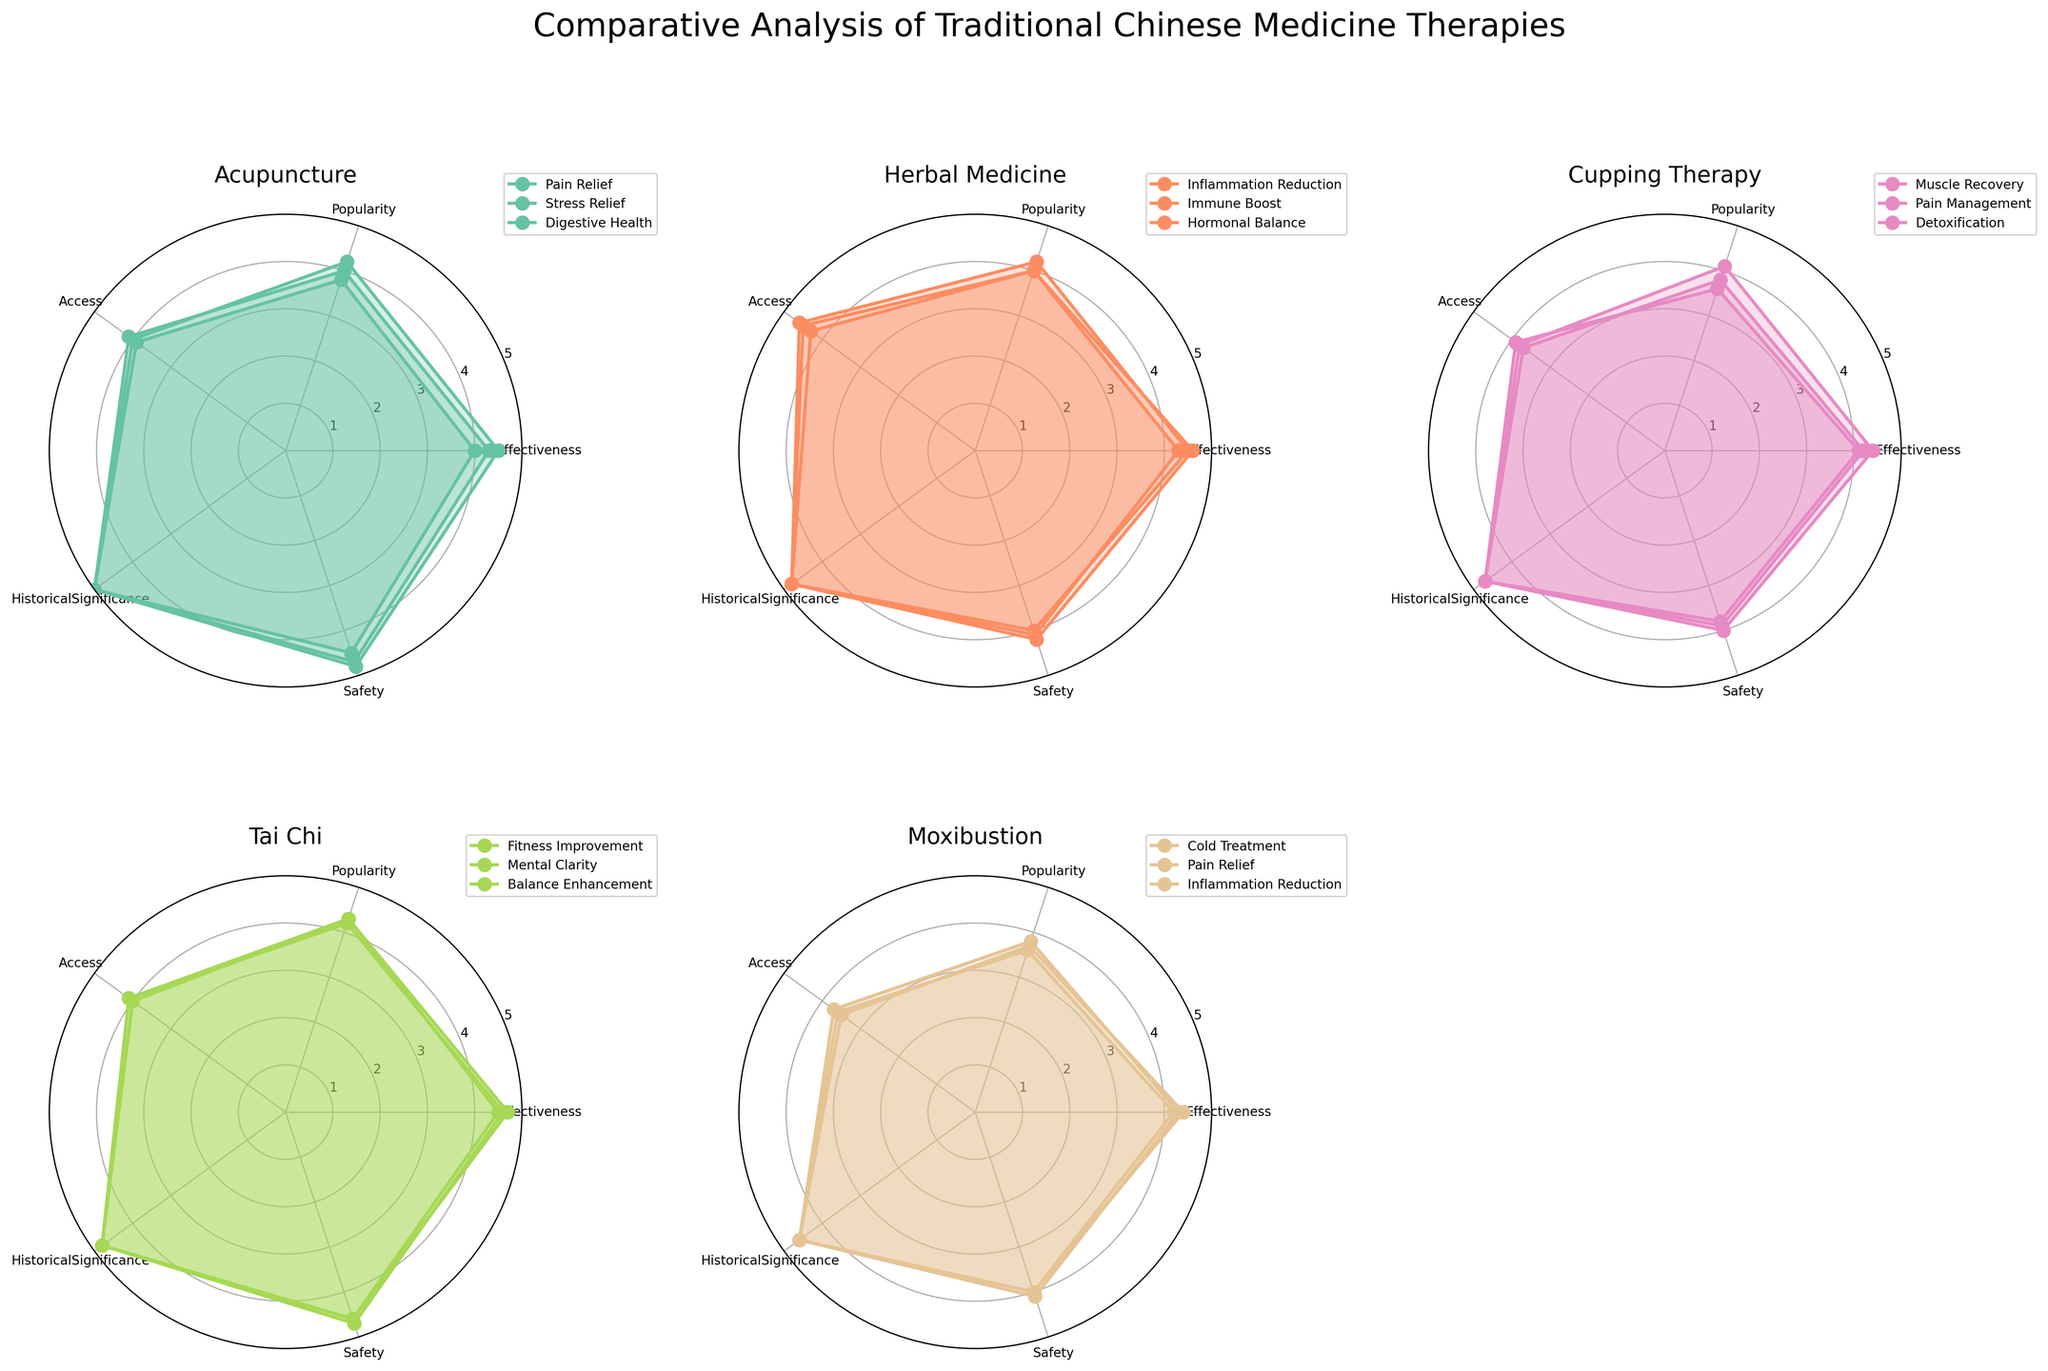Which therapy type has the highest historical significance? By examining the plot, we can see that the historical significance for each therapy type. Acupuncture, Herbal Medicine, Tai Chi, Cupping Therapy, Moxibustion, and Tui Na all have high values, with Acupuncture consistently showing a value of 5.0 across different uses.
Answer: Acupuncture Which attribute is the lowest for Cupping Therapy? Checking the individual subplots for Cupping Therapy reveals the values for each attribute. The Access attribute consistently appears to be the lowest value amongst the plotted data.
Answer: Access Which therapy has the highest effectiveness overall? To determine this, we need to look at each subplot and compare the highest effectiveness ratings across all therapies. Acupuncture for Pain Relief and Herbal Medicine for Inflammation Reduction both have high ratings of 4.6, prompting us to consider these as very effective.
Answer: Acupuncture and Herbal Medicine What is the average effectiveness of Tai Chi therapies? To find this, we add the effectiveness values for Tai Chi (4.5, 4.6, 4.7) and divide by the number of types (3). This would be (4.5 + 4.6 + 4.7) / 3.
Answer: 4.6 Compare the popularity of Acupuncture for Stress Relief to Moxibustion for Cold Treatment. Which is more popular? Looking at the subplots for Acupuncture and Moxibustion, we see that Acupuncture for Stress Relief has a popularity of 4.0, whereas Moxibustion for Cold Treatment has 3.7. Thus, Acupuncture for Stress Relief is more popular.
Answer: Acupuncture for Stress Relief Which therapy type has the most subplots in the figure? Examining the entire layout, each subplot is dedicated to a specific therapy, and they all seem to have the same number of data points.
Answer: All types have equal numbers What is the safety score of Herbal Medicine for Immune Boost? Checking the subplot for Herbal Medicine reveals a safety score for Immune Boost. According to the data, this value is clearly marked.
Answer: 4.0 Which therapy type has the highest flexibility improvement effectiveness? Although many therapies have different effectiveness scores, we look specifically at Tui Na therapy, which includes Flexibility Improvement. Its value stands out as 4.3 in its subplot.
Answer: Tui Na Compare the access scores of Tai Chi and Acupuncture. Which one has higher scores? Looking at the subplots for Tai Chi and Acupuncture, we need to check the Access scores directly. While they both have one score above 4.0, Acupuncture tends to show slightly lower values overall.
Answer: Tai Chi What is the highest efficiency of Tui Na on any health benefit? Examining the subplot for Tui Na indicates that it is most efficient for Pain Management, with an effectiveness score of 4.5, which is the highest effectiveness within its data points.
Answer: Pain Management 